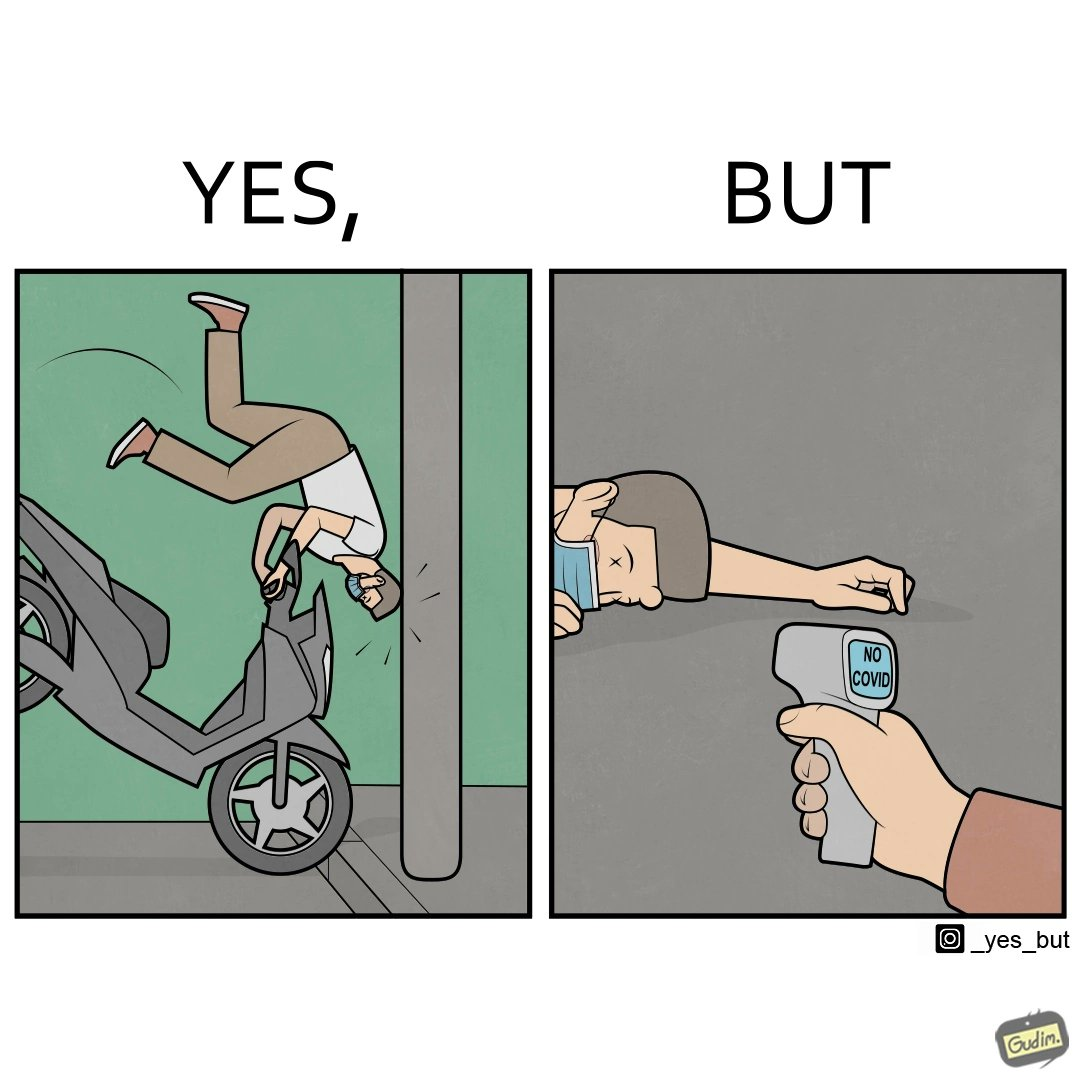Compare the left and right sides of this image. In the left part of the image: a person undergoing a road accident In the right part of the image: a person scanning a dead person for COVID 